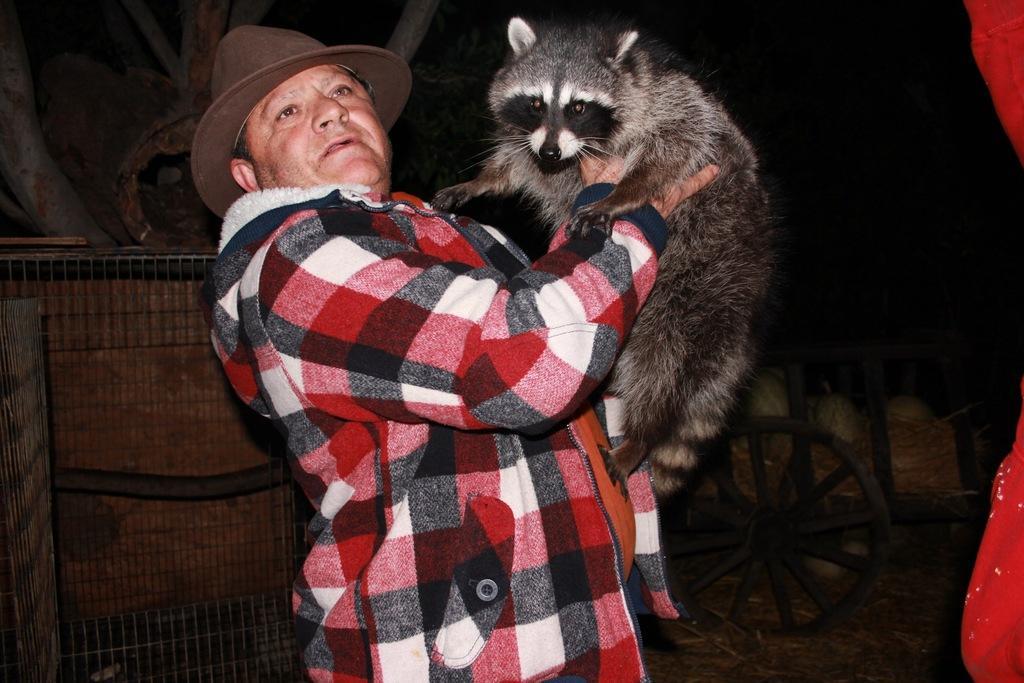Please provide a concise description of this image. In this image we can see a person. There is an animal in the image. There is a wooden cart in the image. There are many objects in the wooden cart. There are few objects at the left side of the image. 